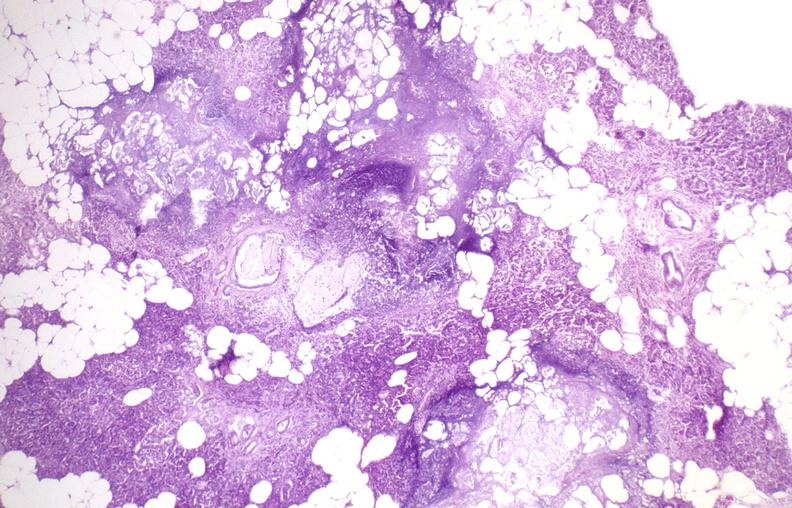does this image show pancreatic fat necrosis?
Answer the question using a single word or phrase. Yes 